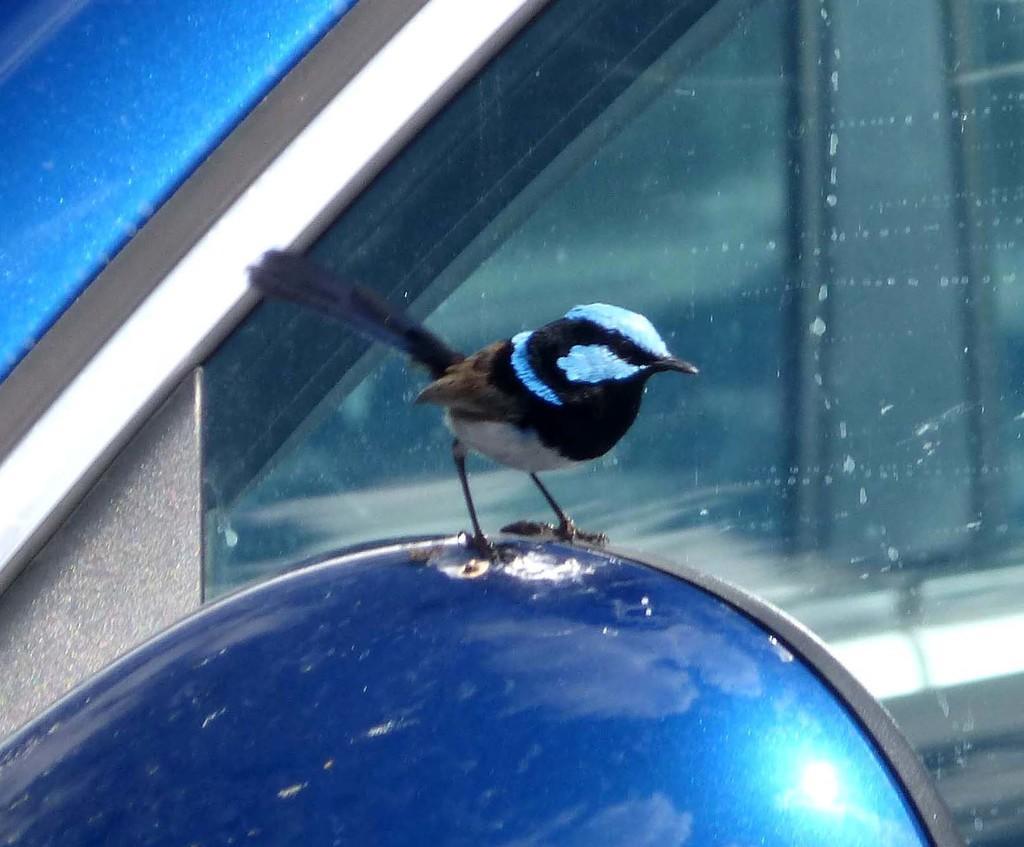Could you give a brief overview of what you see in this image? In this image there is a car, which is in blue color and we can see a bird on the car. 